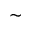<formula> <loc_0><loc_0><loc_500><loc_500>\sim</formula> 